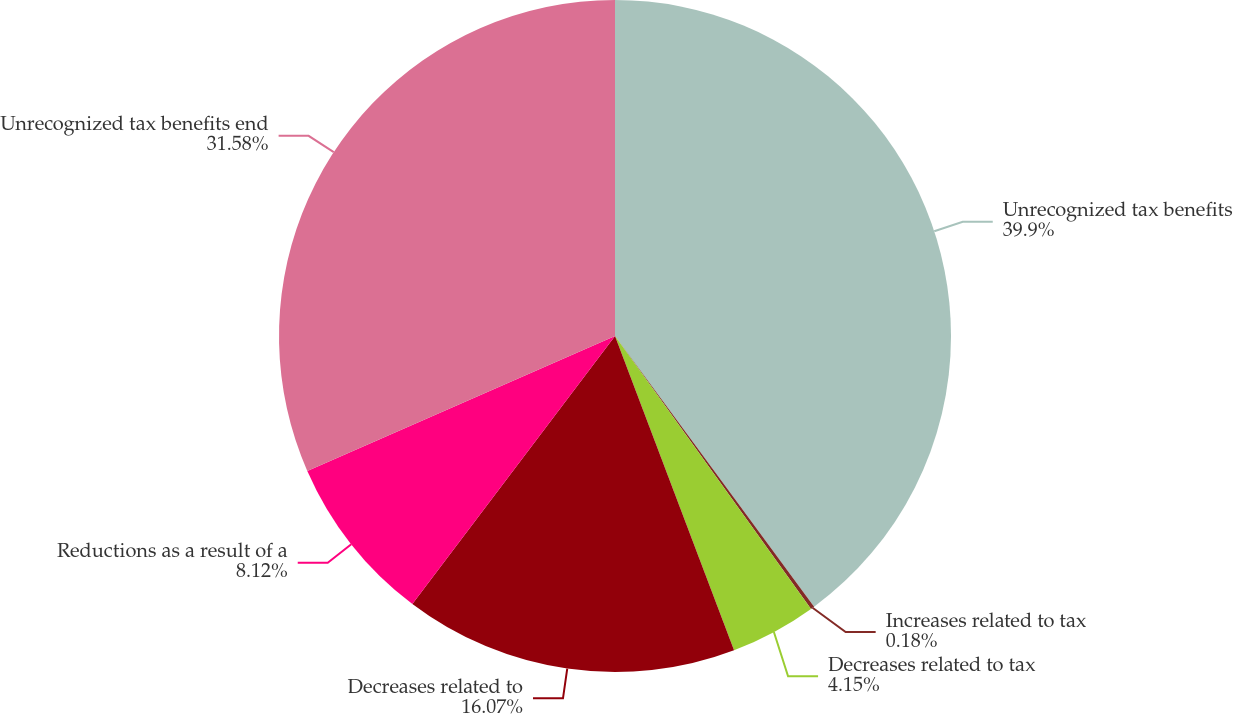<chart> <loc_0><loc_0><loc_500><loc_500><pie_chart><fcel>Unrecognized tax benefits<fcel>Increases related to tax<fcel>Decreases related to tax<fcel>Decreases related to<fcel>Reductions as a result of a<fcel>Unrecognized tax benefits end<nl><fcel>39.91%<fcel>0.18%<fcel>4.15%<fcel>16.07%<fcel>8.12%<fcel>31.58%<nl></chart> 